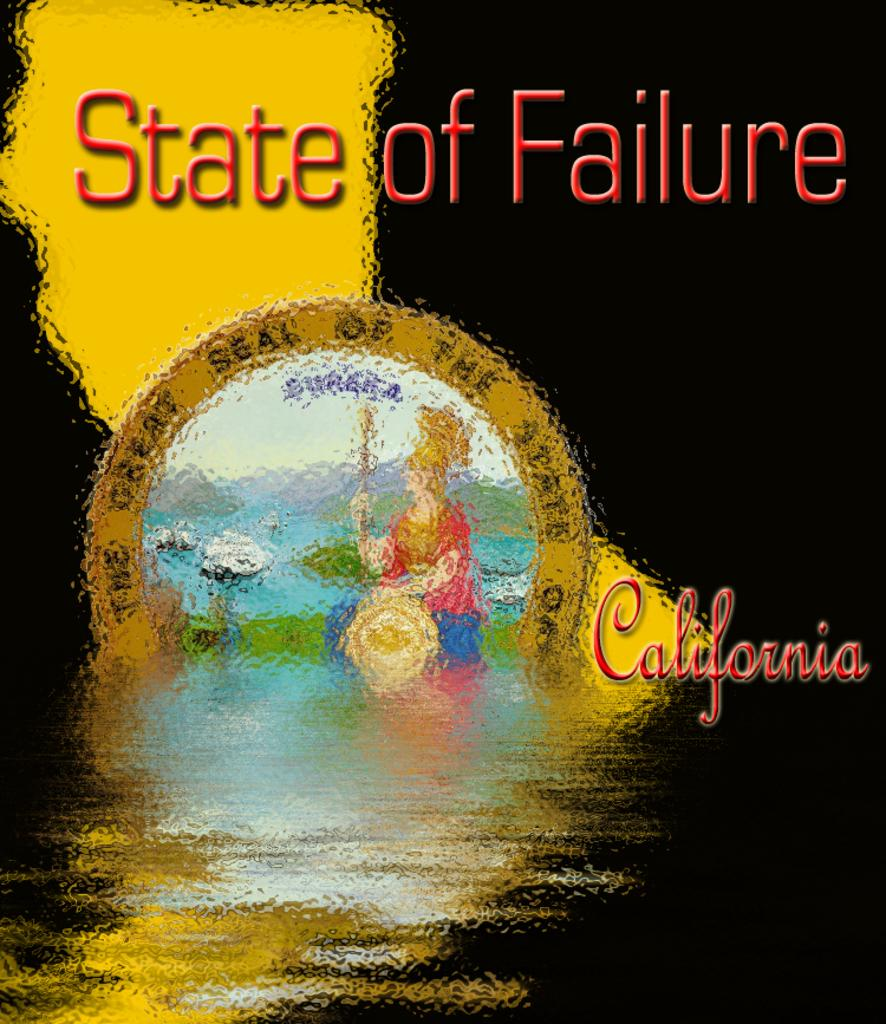<image>
Present a compact description of the photo's key features. A image of the state of California with "State of Failure." 